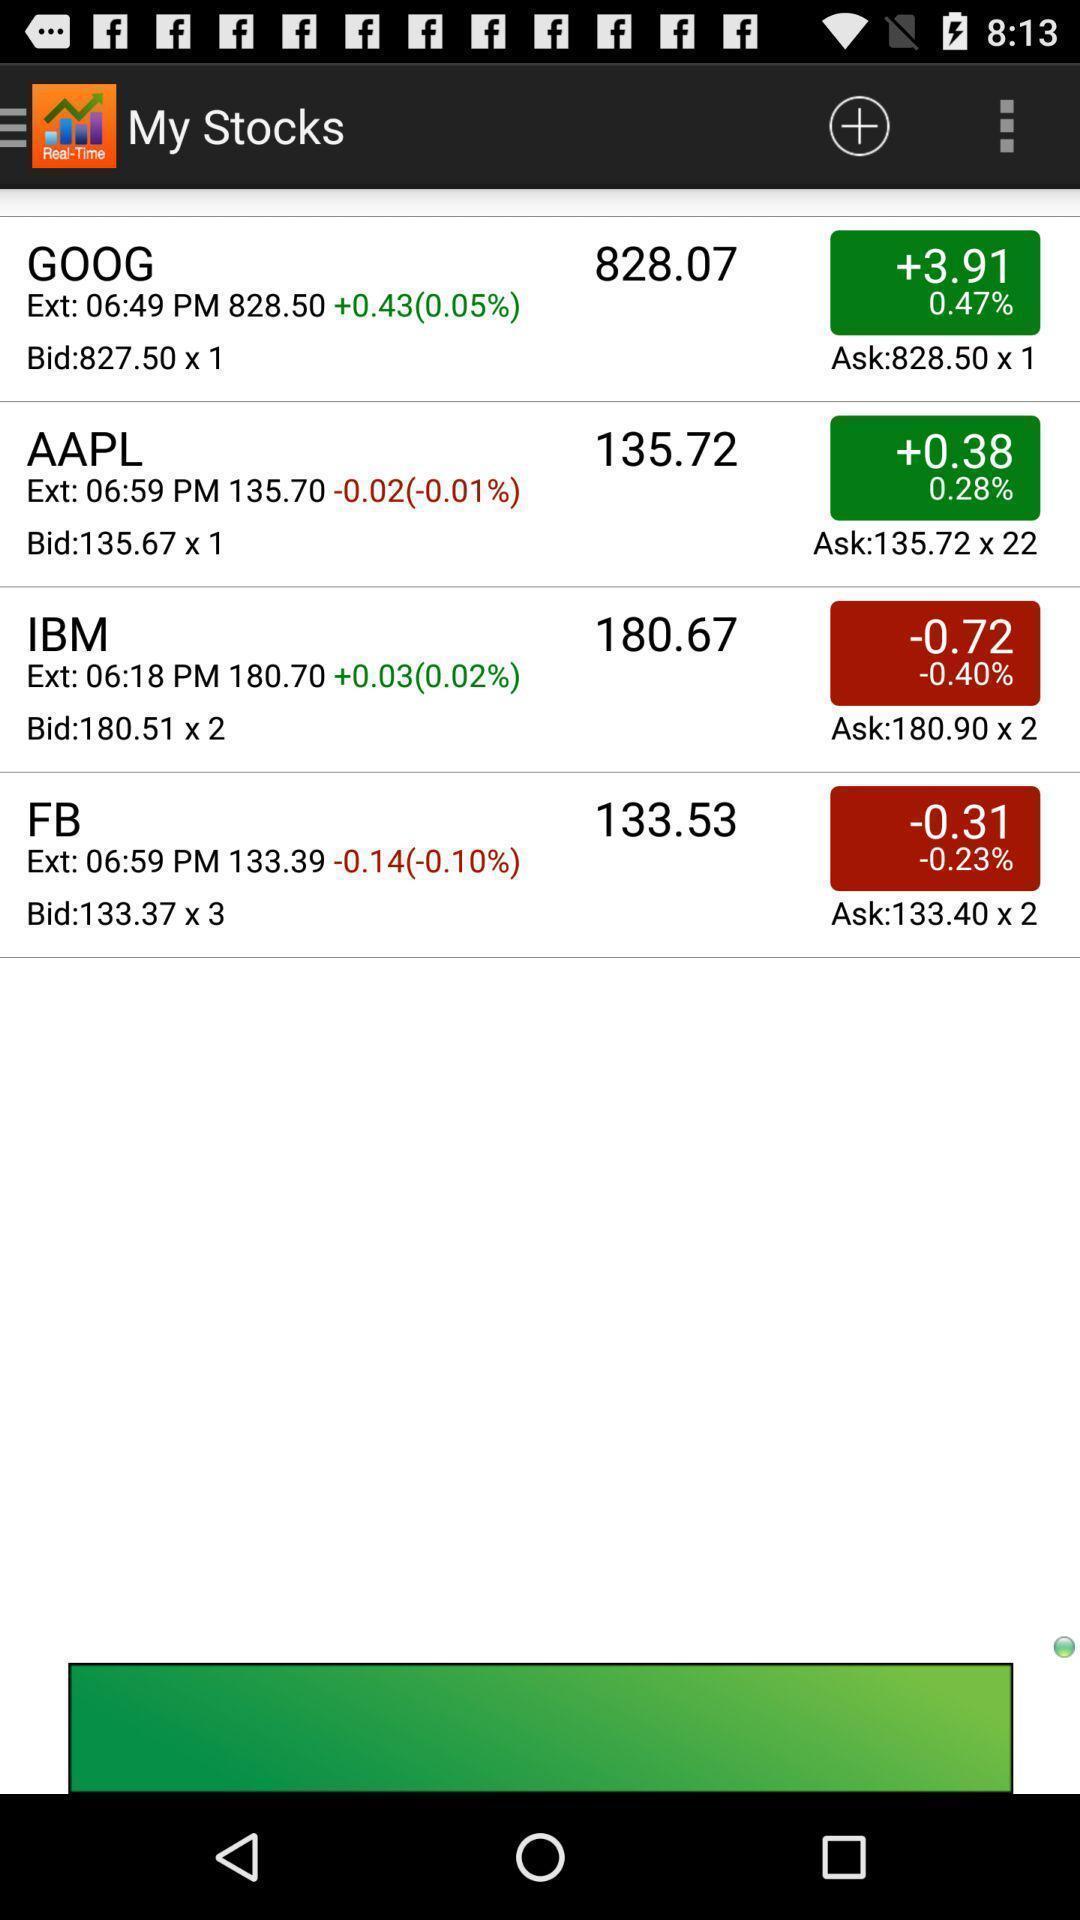Describe this image in words. Page that displaying trading application. 